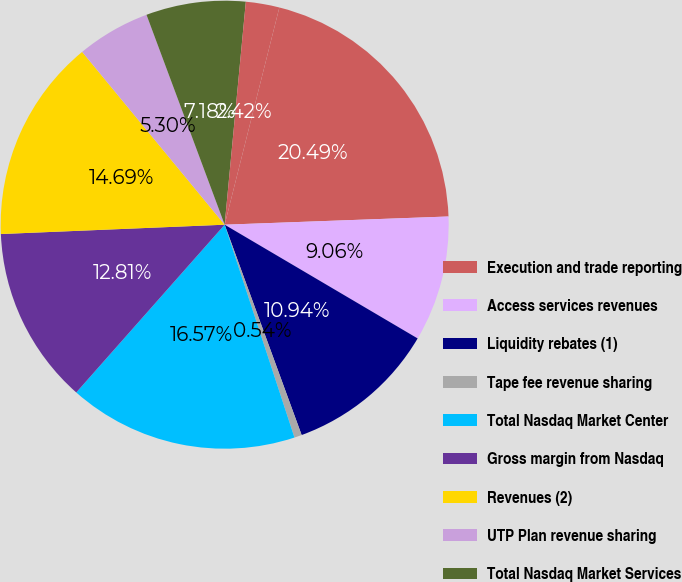<chart> <loc_0><loc_0><loc_500><loc_500><pie_chart><fcel>Execution and trade reporting<fcel>Access services revenues<fcel>Liquidity rebates (1)<fcel>Tape fee revenue sharing<fcel>Total Nasdaq Market Center<fcel>Gross margin from Nasdaq<fcel>Revenues (2)<fcel>UTP Plan revenue sharing<fcel>Total Nasdaq Market Services<fcel>Other Market Services revenues<nl><fcel>20.49%<fcel>9.06%<fcel>10.94%<fcel>0.54%<fcel>16.57%<fcel>12.81%<fcel>14.69%<fcel>5.3%<fcel>7.18%<fcel>2.42%<nl></chart> 